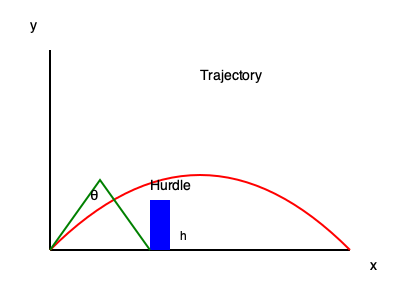As a paralympic runner preparing for a hurdle event, you need to calculate the optimal launch angle (θ) for clearing a hurdle. Given that the hurdle height (h) is 0.914 meters and you need to clear it at a horizontal distance (x) of 3 meters from your starting point, what is the minimum launch angle required? Assume the initial velocity is 8 m/s and neglect air resistance. To find the optimal launch angle, we'll use the projectile motion equations:

1) Horizontal distance: $x = v_0 \cos(\theta) t$
2) Vertical distance: $y = v_0 \sin(\theta) t - \frac{1}{2}gt^2$

Where $v_0$ is the initial velocity, $\theta$ is the launch angle, $t$ is time, and $g$ is the acceleration due to gravity (9.8 m/s²).

Steps:
1. Express time in terms of x:
   $t = \frac{x}{v_0 \cos(\theta)}$

2. Substitute this into the vertical distance equation:
   $h = v_0 \sin(\theta) (\frac{x}{v_0 \cos(\theta)}) - \frac{1}{2}g(\frac{x}{v_0 \cos(\theta)})^2$

3. Simplify:
   $h = x \tan(\theta) - \frac{gx^2}{2v_0^2 \cos^2(\theta)}$

4. Rearrange to get a quadratic equation in $\tan(\theta)$:
   $\frac{gx^2}{2v_0^2} \tan^2(\theta) - x \tan(\theta) + (h + \frac{gx^2}{2v_0^2}) = 0$

5. Solve using the quadratic formula:
   $\tan(\theta) = \frac{x \pm \sqrt{x^2 - 2g(h + \frac{gx^2}{2v_0^2})(\frac{x^2}{v_0^2})}}{gx^2/v_0^2}$

6. Substitute the given values: $h = 0.914$ m, $x = 3$ m, $v_0 = 8$ m/s, $g = 9.8$ m/s²

7. Calculate and take the inverse tangent to find θ:
   $\theta = \arctan(\frac{3 - \sqrt{9 - 2(9.8)(0.914 + \frac{9.8 \cdot 9}{2 \cdot 64})\frac{9}{64}}}{9.8 \cdot 9 / 64})$

8. Solve numerically:
   $\theta \approx 0.4363$ radians

9. Convert to degrees:
   $\theta \approx 25.0°$
Answer: 25.0° 